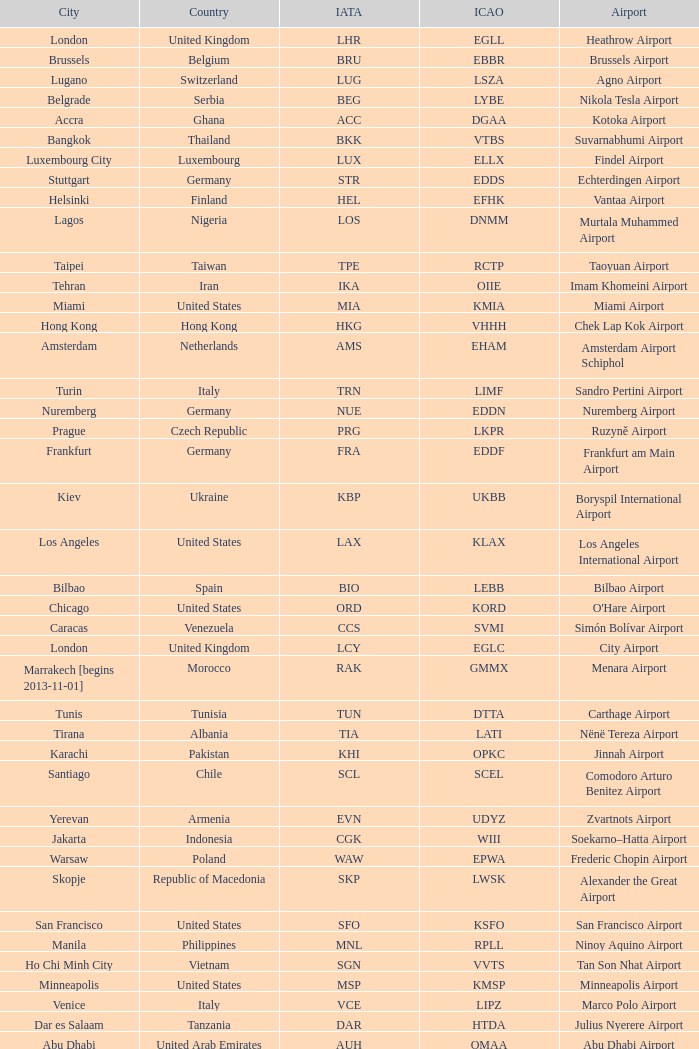What is the ICAO of Douala city? FKKD. 